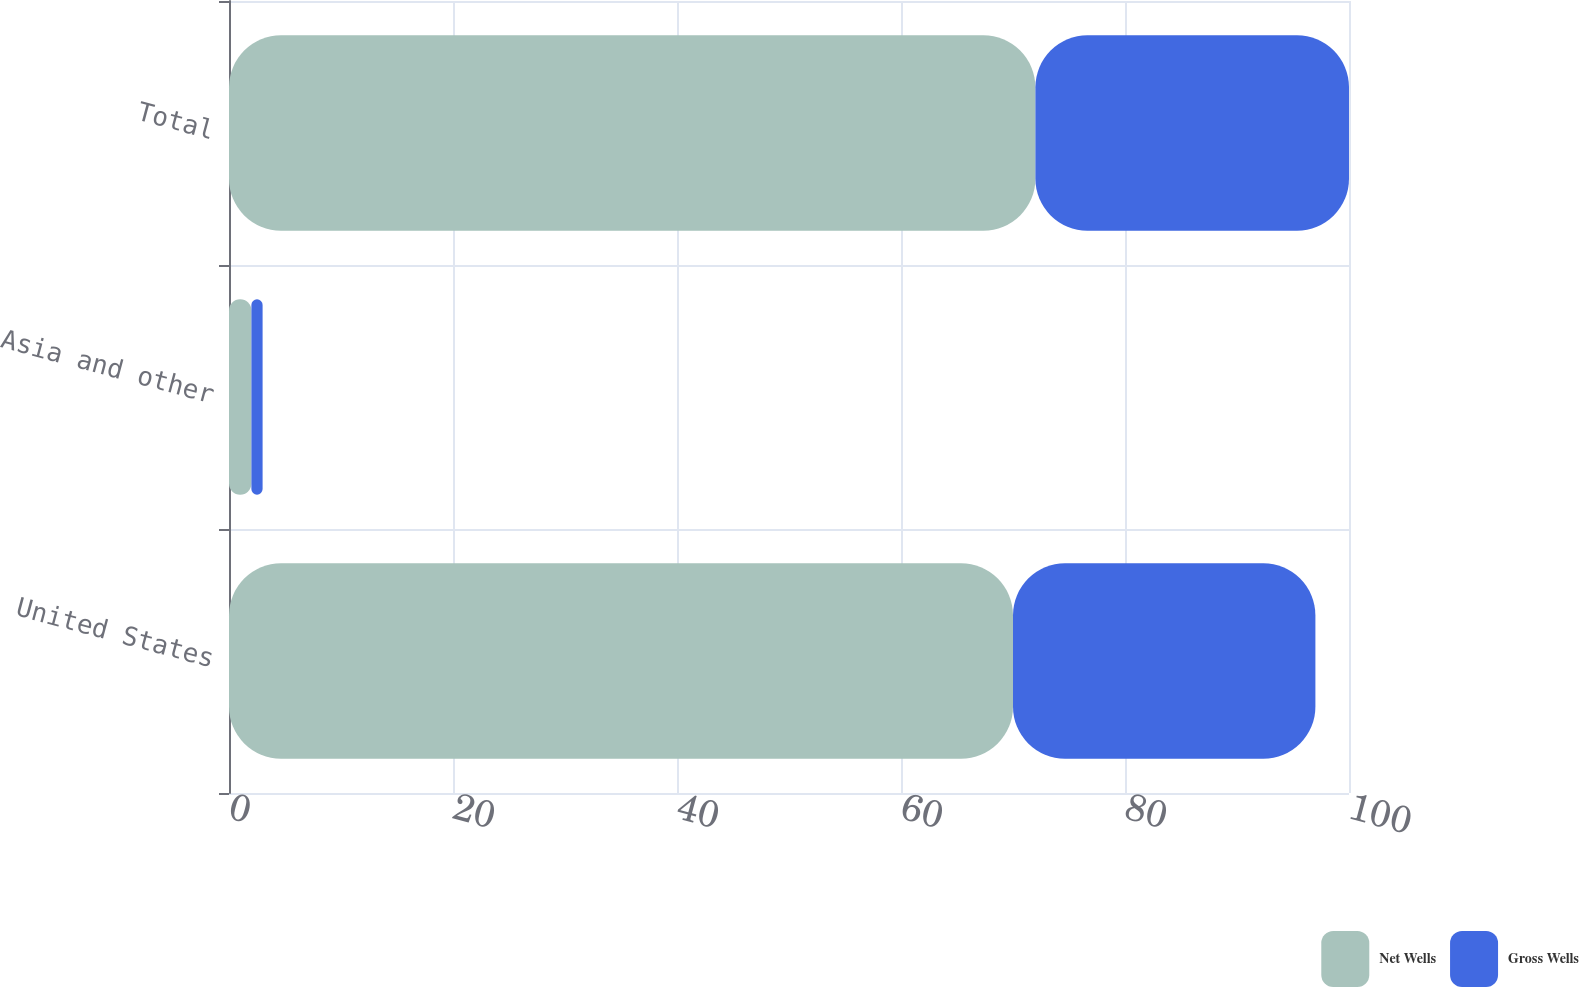<chart> <loc_0><loc_0><loc_500><loc_500><stacked_bar_chart><ecel><fcel>United States<fcel>Asia and other<fcel>Total<nl><fcel>Net Wells<fcel>70<fcel>2<fcel>72<nl><fcel>Gross Wells<fcel>27<fcel>1<fcel>28<nl></chart> 